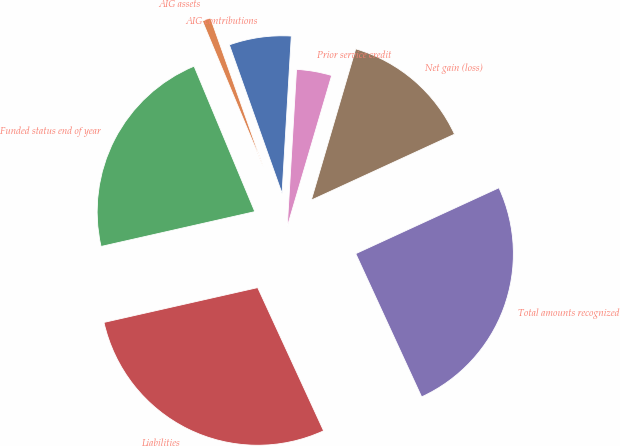Convert chart to OTSL. <chart><loc_0><loc_0><loc_500><loc_500><pie_chart><fcel>AIG contributions<fcel>AIG assets<fcel>Funded status end of year<fcel>Liabilities<fcel>Total amounts recognized<fcel>Net gain (loss)<fcel>Prior service credit<nl><fcel>6.36%<fcel>0.87%<fcel>22.25%<fcel>28.32%<fcel>25.0%<fcel>13.59%<fcel>3.61%<nl></chart> 